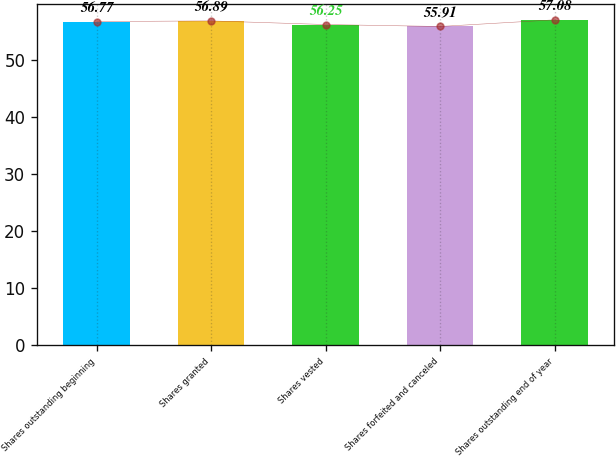Convert chart. <chart><loc_0><loc_0><loc_500><loc_500><bar_chart><fcel>Shares outstanding beginning<fcel>Shares granted<fcel>Shares vested<fcel>Shares forfeited and canceled<fcel>Shares outstanding end of year<nl><fcel>56.77<fcel>56.89<fcel>56.25<fcel>55.91<fcel>57.08<nl></chart> 